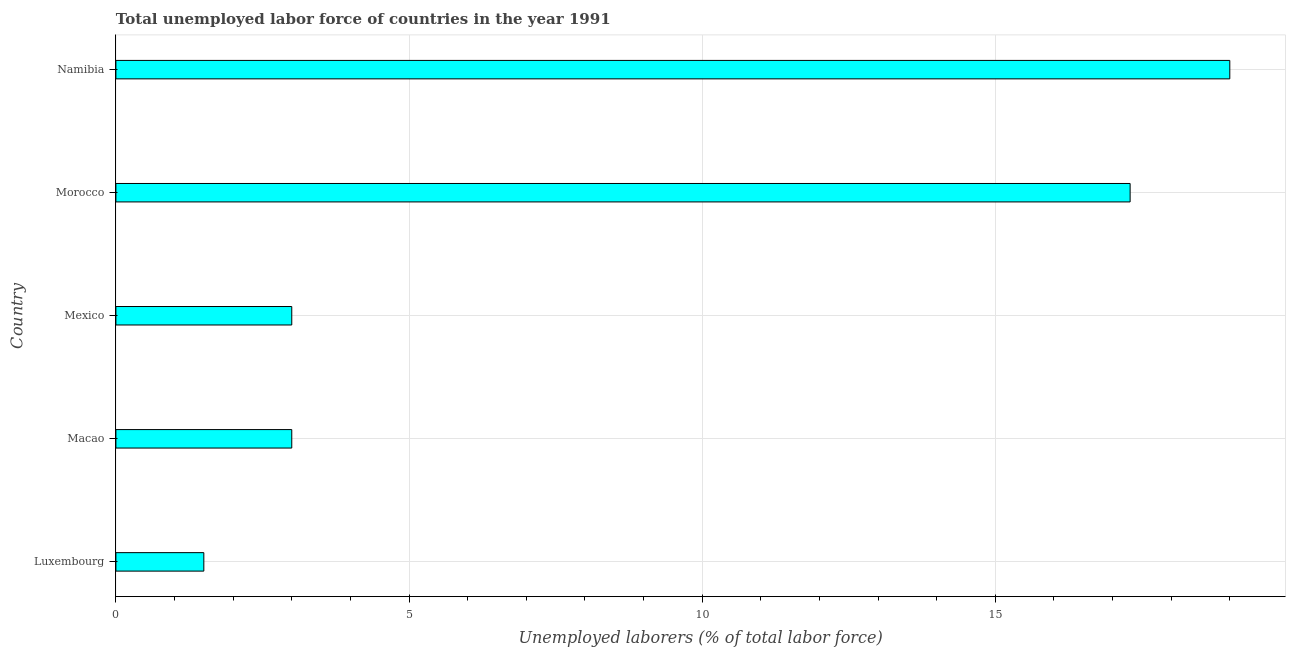Does the graph contain any zero values?
Ensure brevity in your answer.  No. Does the graph contain grids?
Your answer should be compact. Yes. What is the title of the graph?
Offer a very short reply. Total unemployed labor force of countries in the year 1991. What is the label or title of the X-axis?
Your response must be concise. Unemployed laborers (% of total labor force). What is the total unemployed labour force in Morocco?
Offer a very short reply. 17.3. Across all countries, what is the maximum total unemployed labour force?
Offer a terse response. 19. Across all countries, what is the minimum total unemployed labour force?
Ensure brevity in your answer.  1.5. In which country was the total unemployed labour force maximum?
Make the answer very short. Namibia. In which country was the total unemployed labour force minimum?
Provide a short and direct response. Luxembourg. What is the sum of the total unemployed labour force?
Provide a short and direct response. 43.8. What is the difference between the total unemployed labour force in Luxembourg and Morocco?
Give a very brief answer. -15.8. What is the average total unemployed labour force per country?
Your response must be concise. 8.76. What is the ratio of the total unemployed labour force in Luxembourg to that in Namibia?
Provide a short and direct response. 0.08. Is the difference between the total unemployed labour force in Luxembourg and Mexico greater than the difference between any two countries?
Your answer should be very brief. No. In how many countries, is the total unemployed labour force greater than the average total unemployed labour force taken over all countries?
Your answer should be very brief. 2. How many countries are there in the graph?
Your answer should be very brief. 5. What is the difference between two consecutive major ticks on the X-axis?
Your answer should be compact. 5. What is the Unemployed laborers (% of total labor force) of Macao?
Provide a succinct answer. 3. What is the Unemployed laborers (% of total labor force) in Morocco?
Provide a succinct answer. 17.3. What is the difference between the Unemployed laborers (% of total labor force) in Luxembourg and Morocco?
Provide a short and direct response. -15.8. What is the difference between the Unemployed laborers (% of total labor force) in Luxembourg and Namibia?
Offer a very short reply. -17.5. What is the difference between the Unemployed laborers (% of total labor force) in Macao and Mexico?
Your response must be concise. 0. What is the difference between the Unemployed laborers (% of total labor force) in Macao and Morocco?
Keep it short and to the point. -14.3. What is the difference between the Unemployed laborers (% of total labor force) in Macao and Namibia?
Provide a short and direct response. -16. What is the difference between the Unemployed laborers (% of total labor force) in Mexico and Morocco?
Provide a short and direct response. -14.3. What is the difference between the Unemployed laborers (% of total labor force) in Morocco and Namibia?
Provide a succinct answer. -1.7. What is the ratio of the Unemployed laborers (% of total labor force) in Luxembourg to that in Macao?
Your answer should be compact. 0.5. What is the ratio of the Unemployed laborers (% of total labor force) in Luxembourg to that in Mexico?
Ensure brevity in your answer.  0.5. What is the ratio of the Unemployed laborers (% of total labor force) in Luxembourg to that in Morocco?
Make the answer very short. 0.09. What is the ratio of the Unemployed laborers (% of total labor force) in Luxembourg to that in Namibia?
Offer a terse response. 0.08. What is the ratio of the Unemployed laborers (% of total labor force) in Macao to that in Morocco?
Your answer should be compact. 0.17. What is the ratio of the Unemployed laborers (% of total labor force) in Macao to that in Namibia?
Make the answer very short. 0.16. What is the ratio of the Unemployed laborers (% of total labor force) in Mexico to that in Morocco?
Make the answer very short. 0.17. What is the ratio of the Unemployed laborers (% of total labor force) in Mexico to that in Namibia?
Keep it short and to the point. 0.16. What is the ratio of the Unemployed laborers (% of total labor force) in Morocco to that in Namibia?
Make the answer very short. 0.91. 